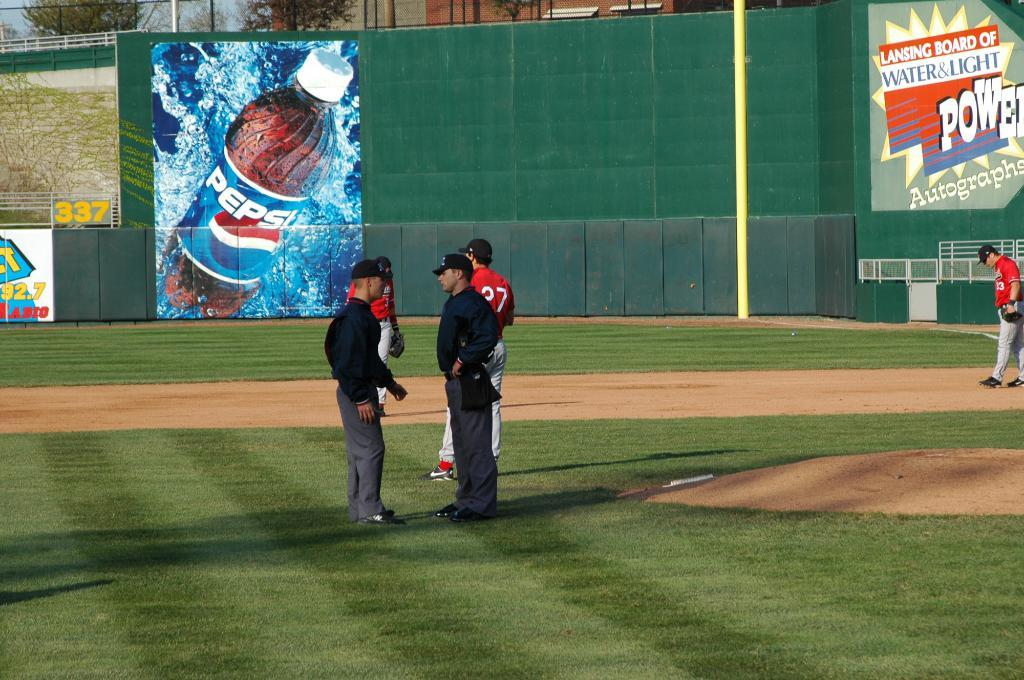<image>
Share a concise interpretation of the image provided. an ad that has the word Pepsi on it 